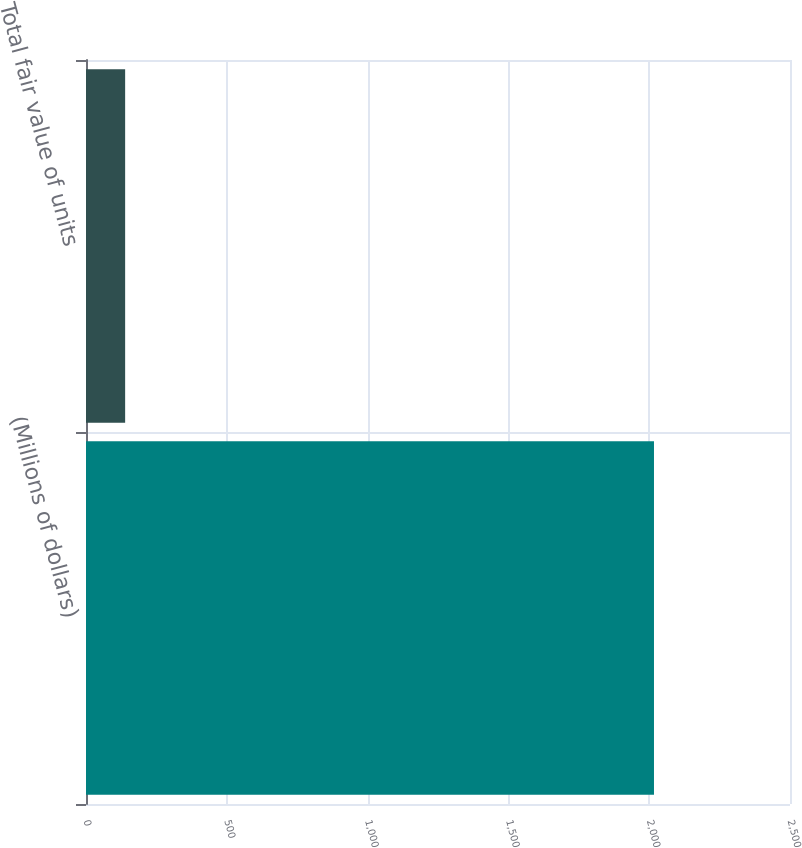Convert chart. <chart><loc_0><loc_0><loc_500><loc_500><bar_chart><fcel>(Millions of dollars)<fcel>Total fair value of units<nl><fcel>2017<fcel>139<nl></chart> 